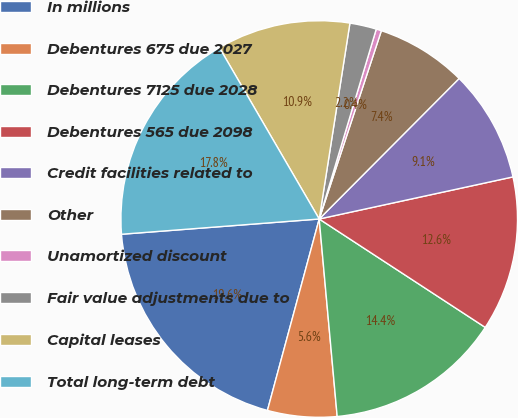Convert chart. <chart><loc_0><loc_0><loc_500><loc_500><pie_chart><fcel>In millions<fcel>Debentures 675 due 2027<fcel>Debentures 7125 due 2028<fcel>Debentures 565 due 2098<fcel>Credit facilities related to<fcel>Other<fcel>Unamortized discount<fcel>Fair value adjustments due to<fcel>Capital leases<fcel>Total long-term debt<nl><fcel>19.57%<fcel>5.65%<fcel>14.35%<fcel>12.61%<fcel>9.13%<fcel>7.39%<fcel>0.43%<fcel>2.17%<fcel>10.87%<fcel>17.83%<nl></chart> 